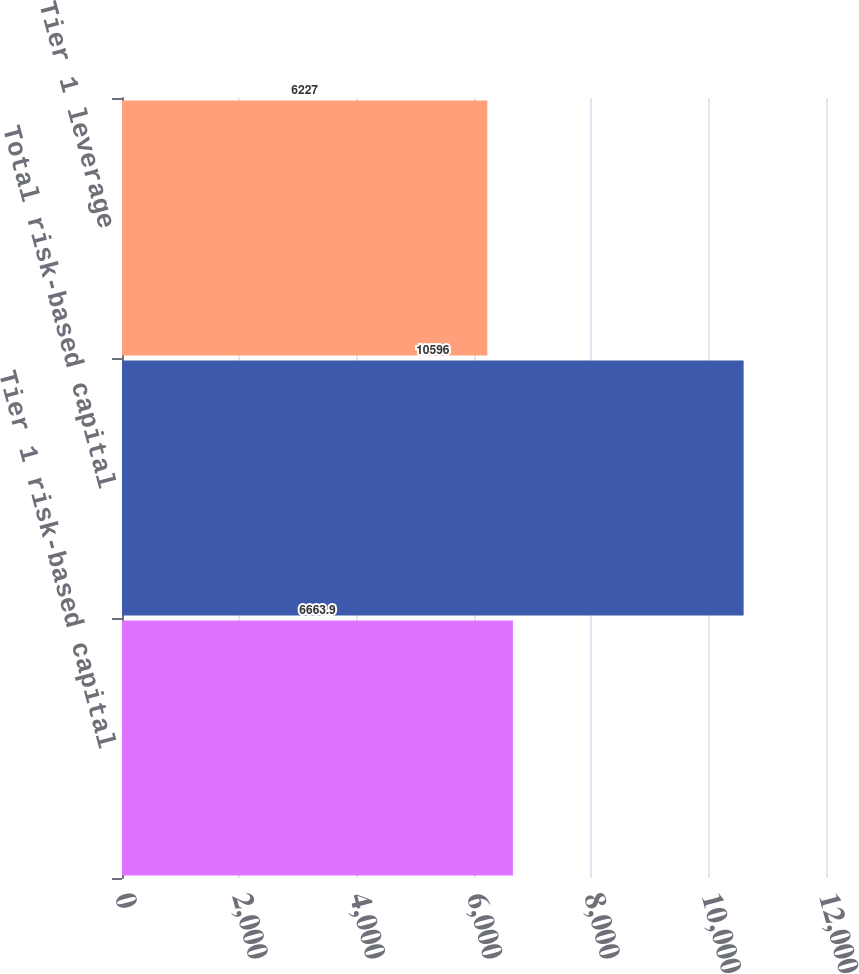Convert chart to OTSL. <chart><loc_0><loc_0><loc_500><loc_500><bar_chart><fcel>Tier 1 risk-based capital<fcel>Total risk-based capital<fcel>Tier 1 leverage<nl><fcel>6663.9<fcel>10596<fcel>6227<nl></chart> 